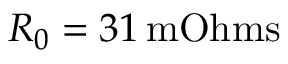Convert formula to latex. <formula><loc_0><loc_0><loc_500><loc_500>R _ { 0 } = 3 1 \, m O h m s</formula> 